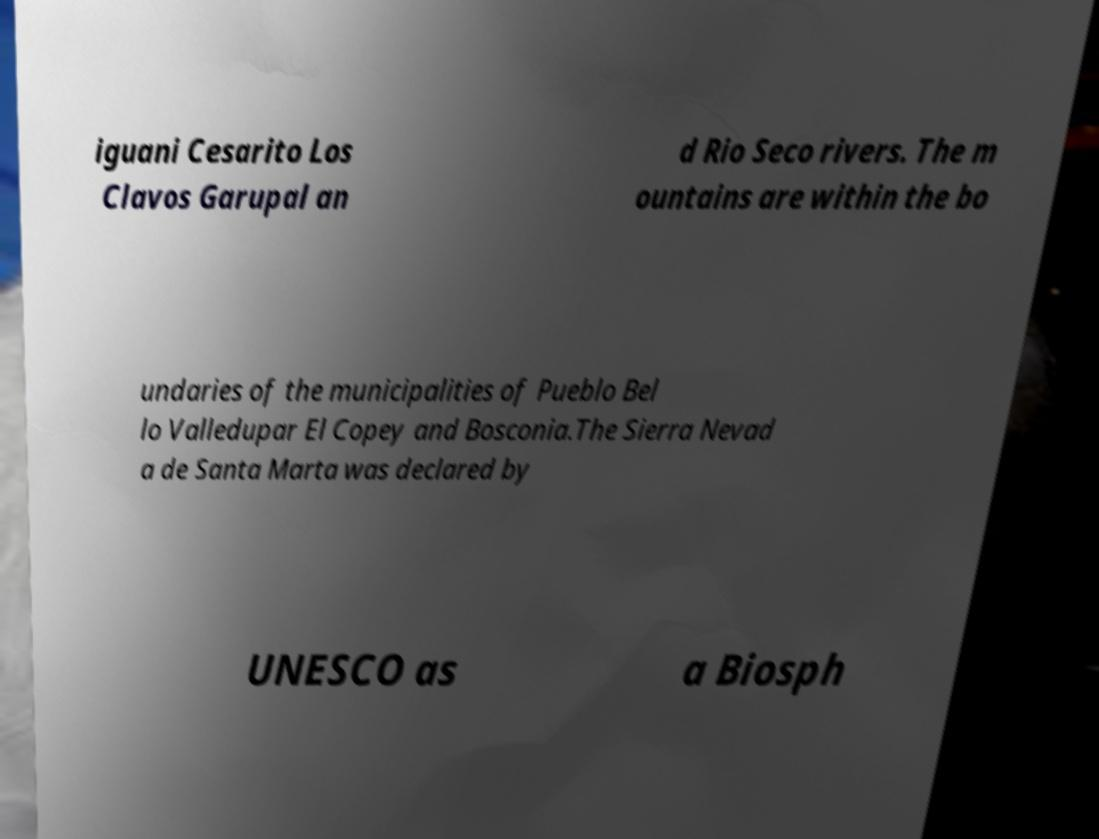Please read and relay the text visible in this image. What does it say? iguani Cesarito Los Clavos Garupal an d Rio Seco rivers. The m ountains are within the bo undaries of the municipalities of Pueblo Bel lo Valledupar El Copey and Bosconia.The Sierra Nevad a de Santa Marta was declared by UNESCO as a Biosph 